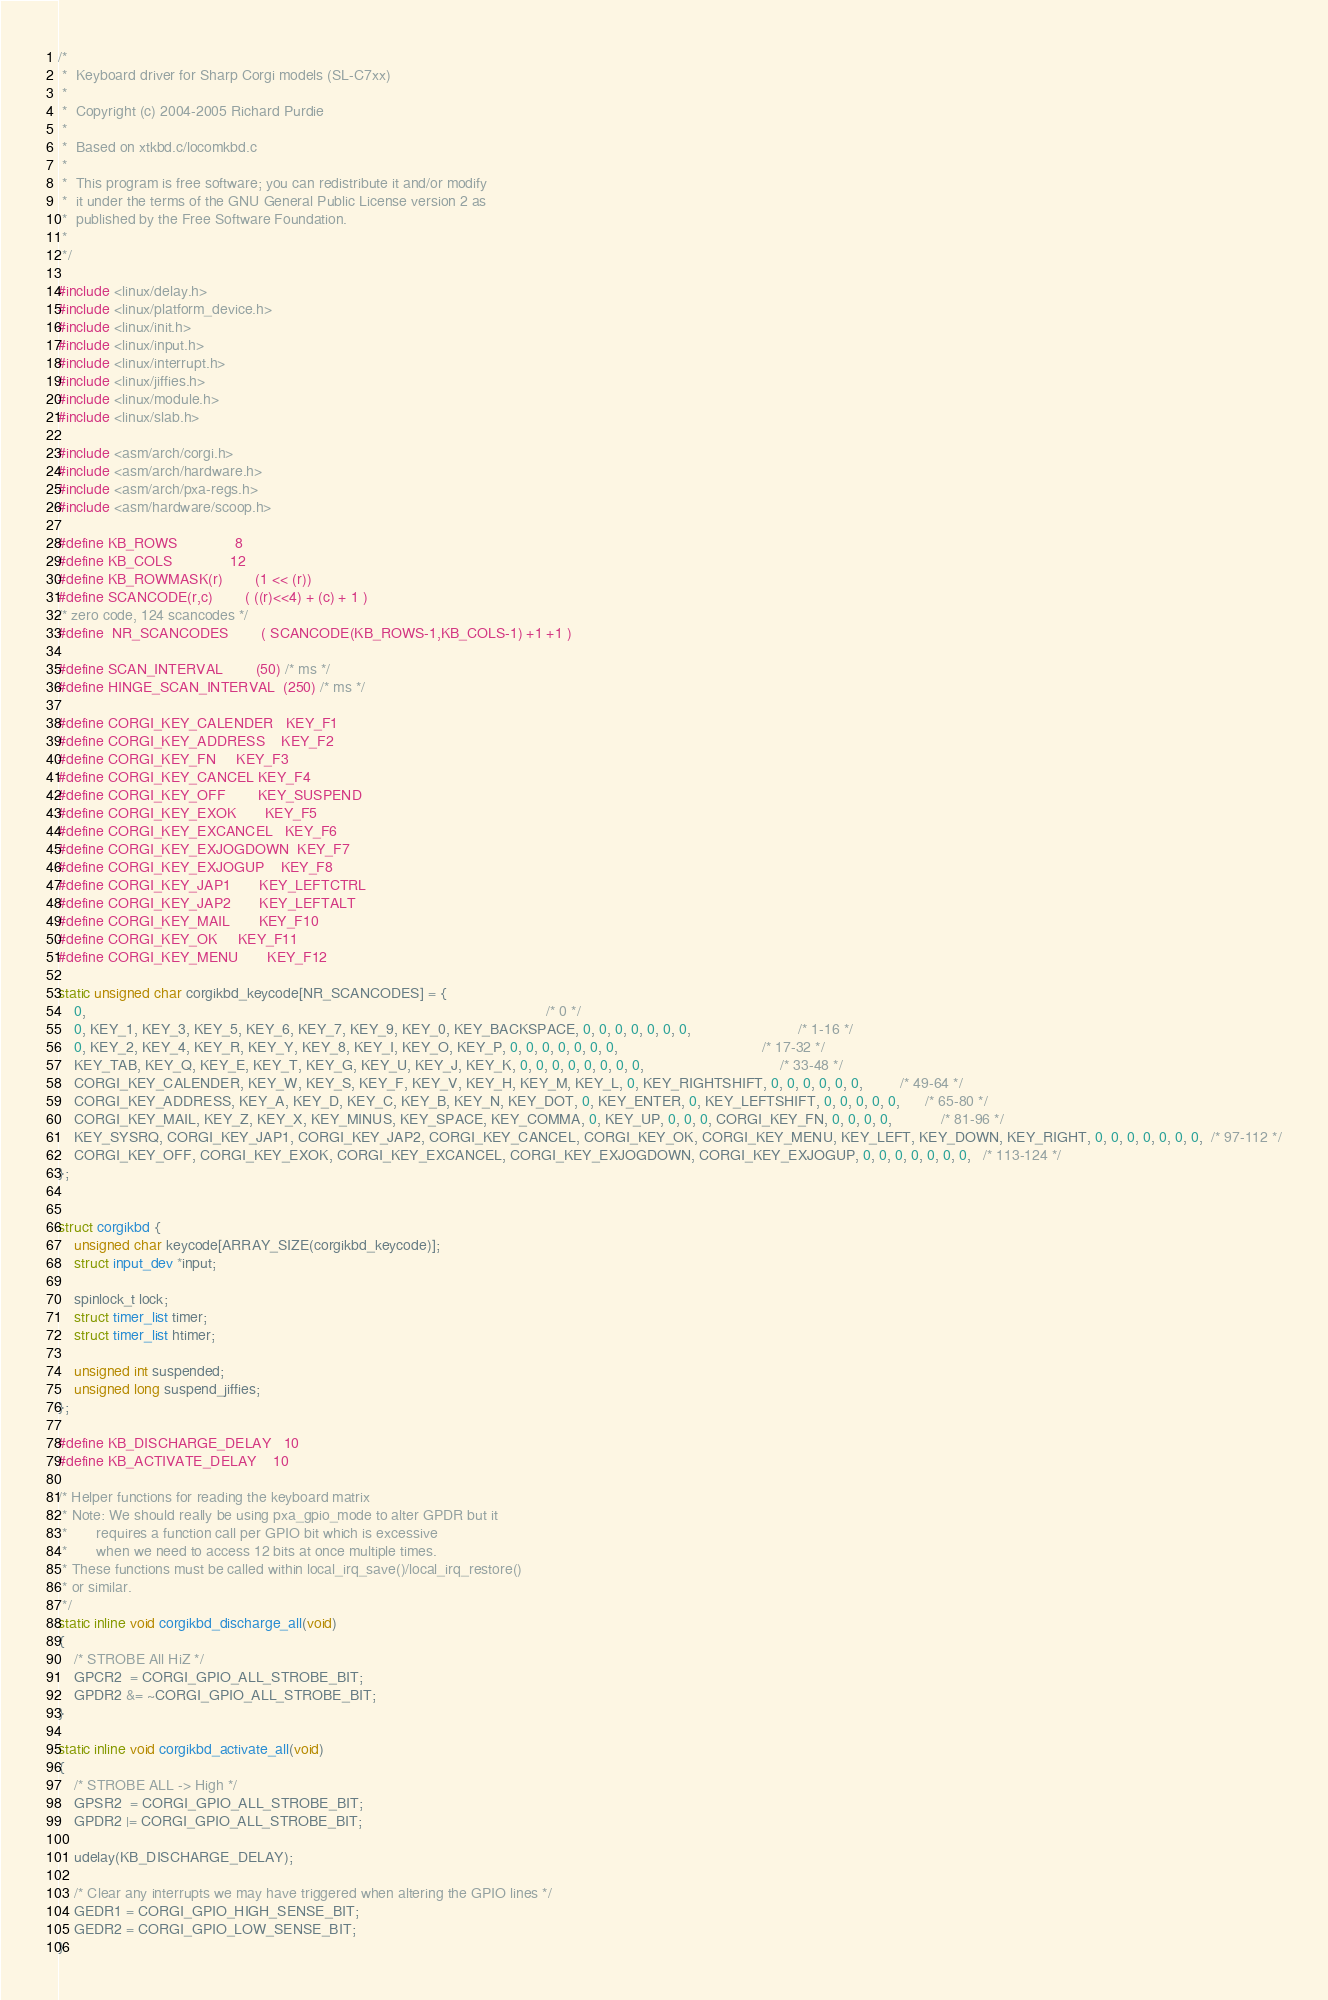Convert code to text. <code><loc_0><loc_0><loc_500><loc_500><_C_>/*
 *  Keyboard driver for Sharp Corgi models (SL-C7xx)
 *
 *  Copyright (c) 2004-2005 Richard Purdie
 *
 *  Based on xtkbd.c/locomkbd.c
 *
 *  This program is free software; you can redistribute it and/or modify
 *  it under the terms of the GNU General Public License version 2 as
 *  published by the Free Software Foundation.
 *
 */

#include <linux/delay.h>
#include <linux/platform_device.h>
#include <linux/init.h>
#include <linux/input.h>
#include <linux/interrupt.h>
#include <linux/jiffies.h>
#include <linux/module.h>
#include <linux/slab.h>

#include <asm/arch/corgi.h>
#include <asm/arch/hardware.h>
#include <asm/arch/pxa-regs.h>
#include <asm/hardware/scoop.h>

#define KB_ROWS				8
#define KB_COLS				12
#define KB_ROWMASK(r)		(1 << (r))
#define SCANCODE(r,c)		( ((r)<<4) + (c) + 1 )
/* zero code, 124 scancodes */
#define	NR_SCANCODES		( SCANCODE(KB_ROWS-1,KB_COLS-1) +1 +1 )

#define SCAN_INTERVAL		(50) /* ms */
#define HINGE_SCAN_INTERVAL	(250) /* ms */

#define CORGI_KEY_CALENDER	KEY_F1
#define CORGI_KEY_ADDRESS	KEY_F2
#define CORGI_KEY_FN		KEY_F3
#define CORGI_KEY_CANCEL	KEY_F4
#define CORGI_KEY_OFF		KEY_SUSPEND
#define CORGI_KEY_EXOK		KEY_F5
#define CORGI_KEY_EXCANCEL	KEY_F6
#define CORGI_KEY_EXJOGDOWN	KEY_F7
#define CORGI_KEY_EXJOGUP	KEY_F8
#define CORGI_KEY_JAP1		KEY_LEFTCTRL
#define CORGI_KEY_JAP2		KEY_LEFTALT
#define CORGI_KEY_MAIL		KEY_F10
#define CORGI_KEY_OK		KEY_F11
#define CORGI_KEY_MENU		KEY_F12

static unsigned char corgikbd_keycode[NR_SCANCODES] = {
	0,                                                                                                                /* 0 */
	0, KEY_1, KEY_3, KEY_5, KEY_6, KEY_7, KEY_9, KEY_0, KEY_BACKSPACE, 0, 0, 0, 0, 0, 0, 0, 	                      /* 1-16 */
	0, KEY_2, KEY_4, KEY_R, KEY_Y, KEY_8, KEY_I, KEY_O, KEY_P, 0, 0, 0, 0, 0, 0, 0,                                   /* 17-32 */
	KEY_TAB, KEY_Q, KEY_E, KEY_T, KEY_G, KEY_U, KEY_J, KEY_K, 0, 0, 0, 0, 0, 0, 0, 0,                                 /* 33-48 */
	CORGI_KEY_CALENDER, KEY_W, KEY_S, KEY_F, KEY_V, KEY_H, KEY_M, KEY_L, 0, KEY_RIGHTSHIFT, 0, 0, 0, 0, 0, 0,         /* 49-64 */
	CORGI_KEY_ADDRESS, KEY_A, KEY_D, KEY_C, KEY_B, KEY_N, KEY_DOT, 0, KEY_ENTER, 0, KEY_LEFTSHIFT, 0, 0, 0, 0, 0, 	  /* 65-80 */
	CORGI_KEY_MAIL, KEY_Z, KEY_X, KEY_MINUS, KEY_SPACE, KEY_COMMA, 0, KEY_UP, 0, 0, 0, CORGI_KEY_FN, 0, 0, 0, 0,            /* 81-96 */
	KEY_SYSRQ, CORGI_KEY_JAP1, CORGI_KEY_JAP2, CORGI_KEY_CANCEL, CORGI_KEY_OK, CORGI_KEY_MENU, KEY_LEFT, KEY_DOWN, KEY_RIGHT, 0, 0, 0, 0, 0, 0, 0,  /* 97-112 */
	CORGI_KEY_OFF, CORGI_KEY_EXOK, CORGI_KEY_EXCANCEL, CORGI_KEY_EXJOGDOWN, CORGI_KEY_EXJOGUP, 0, 0, 0, 0, 0, 0, 0,   /* 113-124 */
};


struct corgikbd {
	unsigned char keycode[ARRAY_SIZE(corgikbd_keycode)];
	struct input_dev *input;

	spinlock_t lock;
	struct timer_list timer;
	struct timer_list htimer;

	unsigned int suspended;
	unsigned long suspend_jiffies;
};

#define KB_DISCHARGE_DELAY	10
#define KB_ACTIVATE_DELAY	10

/* Helper functions for reading the keyboard matrix
 * Note: We should really be using pxa_gpio_mode to alter GPDR but it
 *       requires a function call per GPIO bit which is excessive
 *       when we need to access 12 bits at once multiple times.
 * These functions must be called within local_irq_save()/local_irq_restore()
 * or similar.
 */
static inline void corgikbd_discharge_all(void)
{
	/* STROBE All HiZ */
	GPCR2  = CORGI_GPIO_ALL_STROBE_BIT;
	GPDR2 &= ~CORGI_GPIO_ALL_STROBE_BIT;
}

static inline void corgikbd_activate_all(void)
{
	/* STROBE ALL -> High */
	GPSR2  = CORGI_GPIO_ALL_STROBE_BIT;
	GPDR2 |= CORGI_GPIO_ALL_STROBE_BIT;

	udelay(KB_DISCHARGE_DELAY);

	/* Clear any interrupts we may have triggered when altering the GPIO lines */
	GEDR1 = CORGI_GPIO_HIGH_SENSE_BIT;
	GEDR2 = CORGI_GPIO_LOW_SENSE_BIT;
}
</code> 